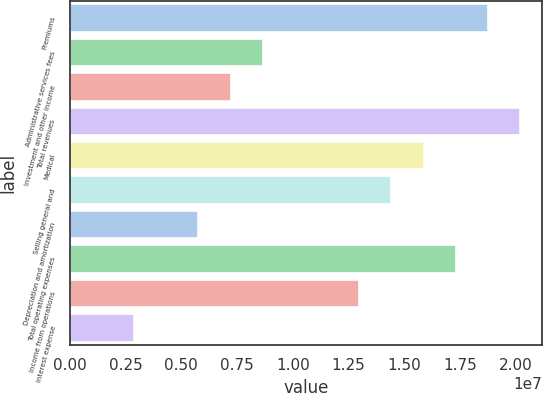<chart> <loc_0><loc_0><loc_500><loc_500><bar_chart><fcel>Premiums<fcel>Administrative services fees<fcel>Investment and other income<fcel>Total revenues<fcel>Medical<fcel>Selling general and<fcel>Depreciation and amortization<fcel>Total operating expenses<fcel>Income from operations<fcel>Interest expense<nl><fcel>1.87436e+07<fcel>8.65088e+06<fcel>7.20906e+06<fcel>2.01854e+07<fcel>1.58599e+07<fcel>1.44181e+07<fcel>5.76725e+06<fcel>1.73018e+07<fcel>1.29763e+07<fcel>2.88363e+06<nl></chart> 